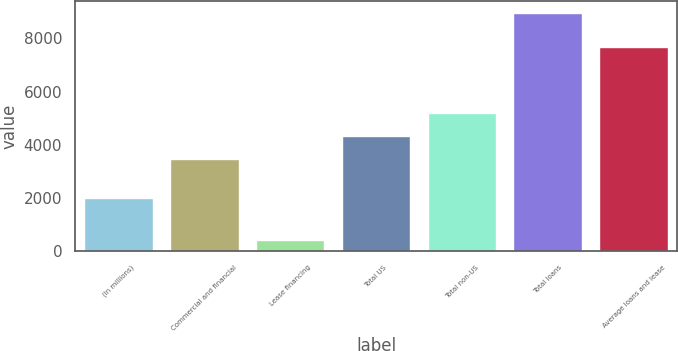Convert chart. <chart><loc_0><loc_0><loc_500><loc_500><bar_chart><fcel>(In millions)<fcel>Commercial and financial<fcel>Lease financing<fcel>Total US<fcel>Total non-US<fcel>Total loans<fcel>Average loans and lease<nl><fcel>2006<fcel>3480<fcel>415<fcel>4333.1<fcel>5186.2<fcel>8946<fcel>7670<nl></chart> 